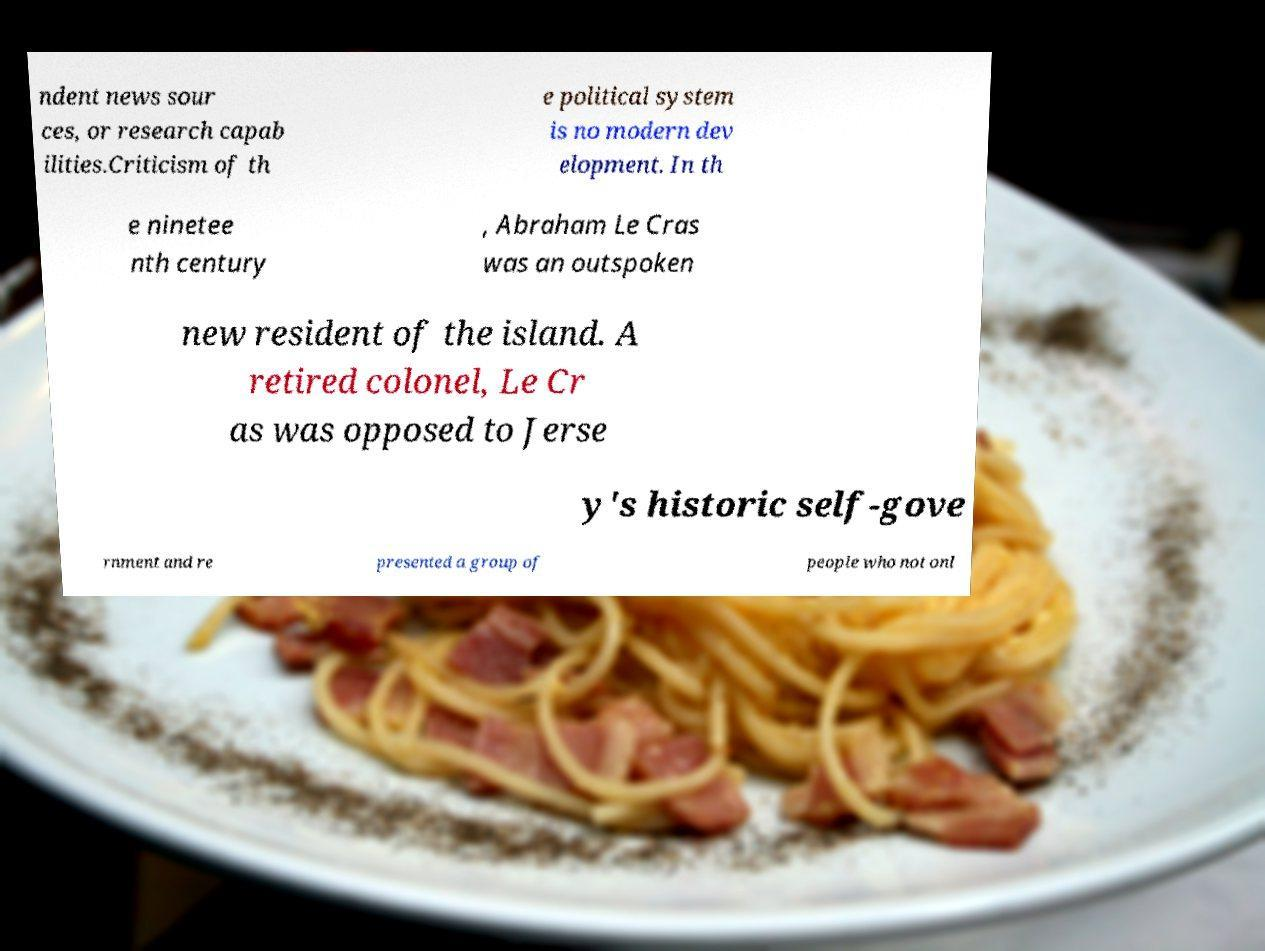What messages or text are displayed in this image? I need them in a readable, typed format. ndent news sour ces, or research capab ilities.Criticism of th e political system is no modern dev elopment. In th e ninetee nth century , Abraham Le Cras was an outspoken new resident of the island. A retired colonel, Le Cr as was opposed to Jerse y's historic self-gove rnment and re presented a group of people who not onl 